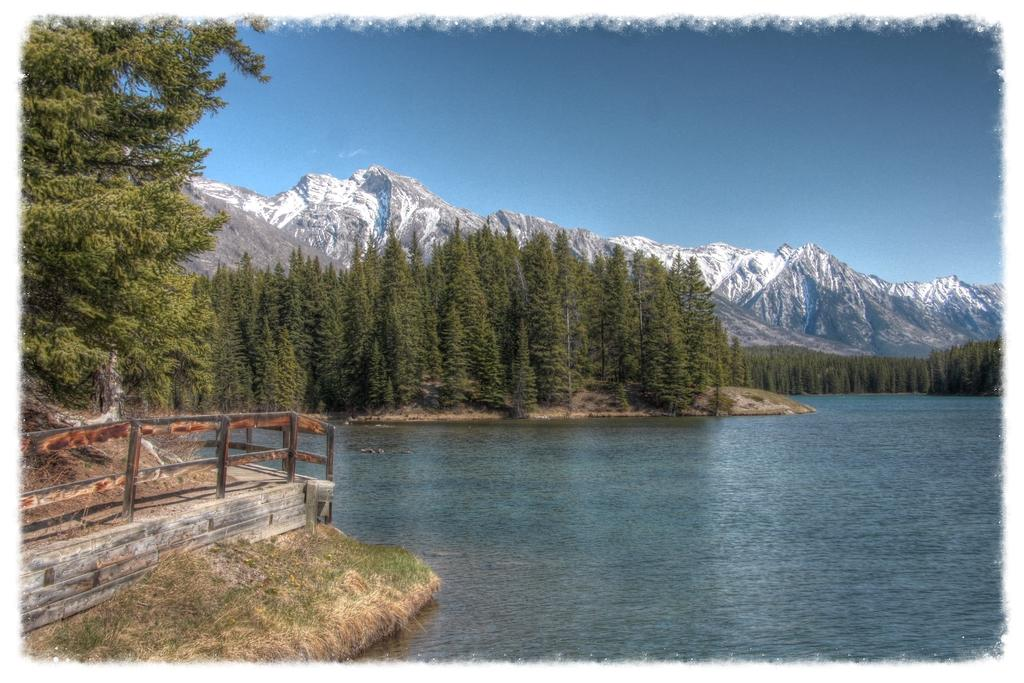What body of water is visible in the image? There is a lake in the image. What can be seen around the lake? There are trees around the lake. Is there any man-made structure near the lake? Yes, there is a bridge near the lake. What is visible in the background of the image? There are trees and mountains in the background of the image. What type of roof can be seen on the lake in the image? There is no roof present on the lake in the image. 